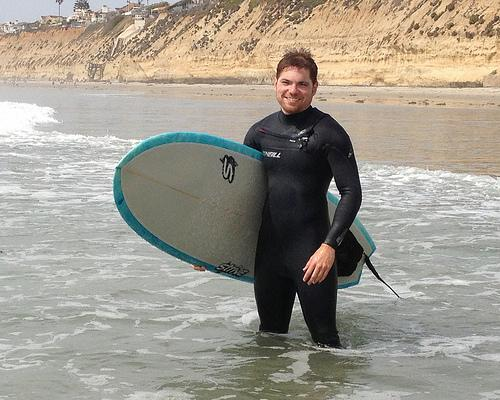Question: why is the man wearing a wetsuit?
Choices:
A. To stay warm.
B. For protection.
C. For style.
D. For his sport.
Answer with the letter. Answer: A Question: where is the man standing?
Choices:
A. Ocean.
B. By a car.
C. In the street.
D. On a patio.
Answer with the letter. Answer: A Question: what color is the surfboard?
Choices:
A. Green.
B. Blue.
C. White.
D. Black.
Answer with the letter. Answer: C Question: what is the man going to do?
Choices:
A. Skate.
B. Surf.
C. Dance.
D. Play football.
Answer with the letter. Answer: B Question: what color is the man's wetsuit?
Choices:
A. Blue.
B. Green.
C. Black.
D. Grey.
Answer with the letter. Answer: C Question: what color are the cliffs in the background?
Choices:
A. Gray.
B. Brown.
C. White.
D. Red.
Answer with the letter. Answer: B 